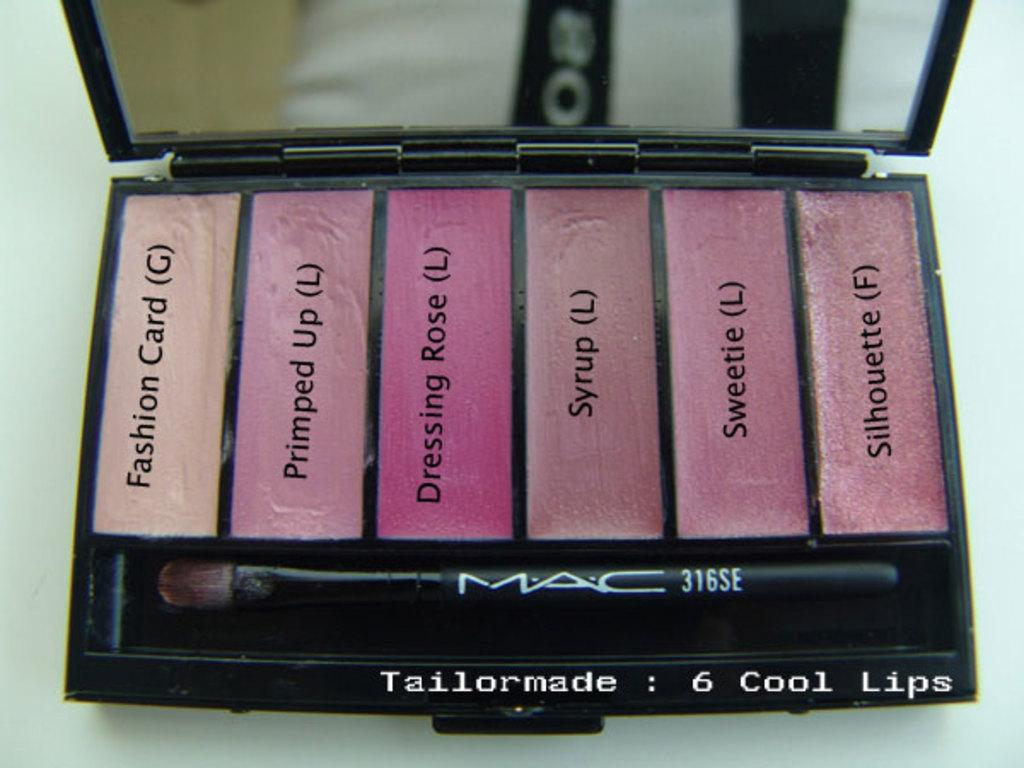<image>
Summarize the visual content of the image. A makeup color pallete with colors like Syrup, Dressing Rose and Primped Up. 